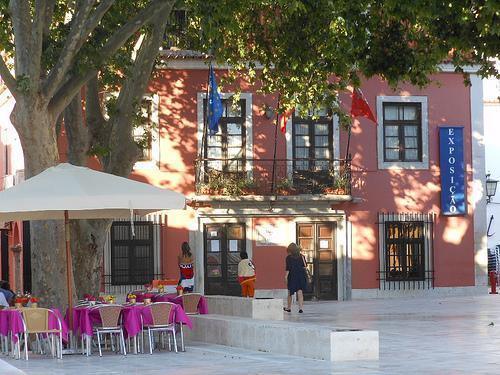How many flags are in the photo?
Give a very brief answer. 3. How many people are in the picture?
Give a very brief answer. 3. 